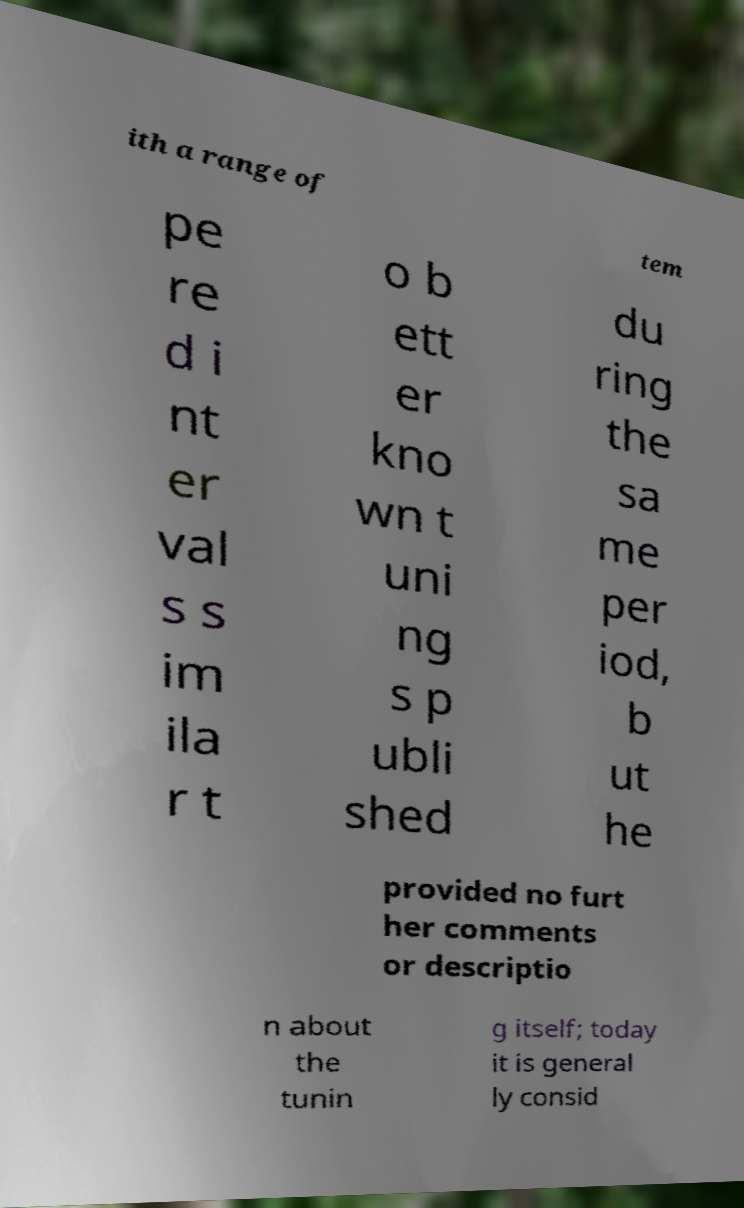Could you extract and type out the text from this image? ith a range of tem pe re d i nt er val s s im ila r t o b ett er kno wn t uni ng s p ubli shed du ring the sa me per iod, b ut he provided no furt her comments or descriptio n about the tunin g itself; today it is general ly consid 